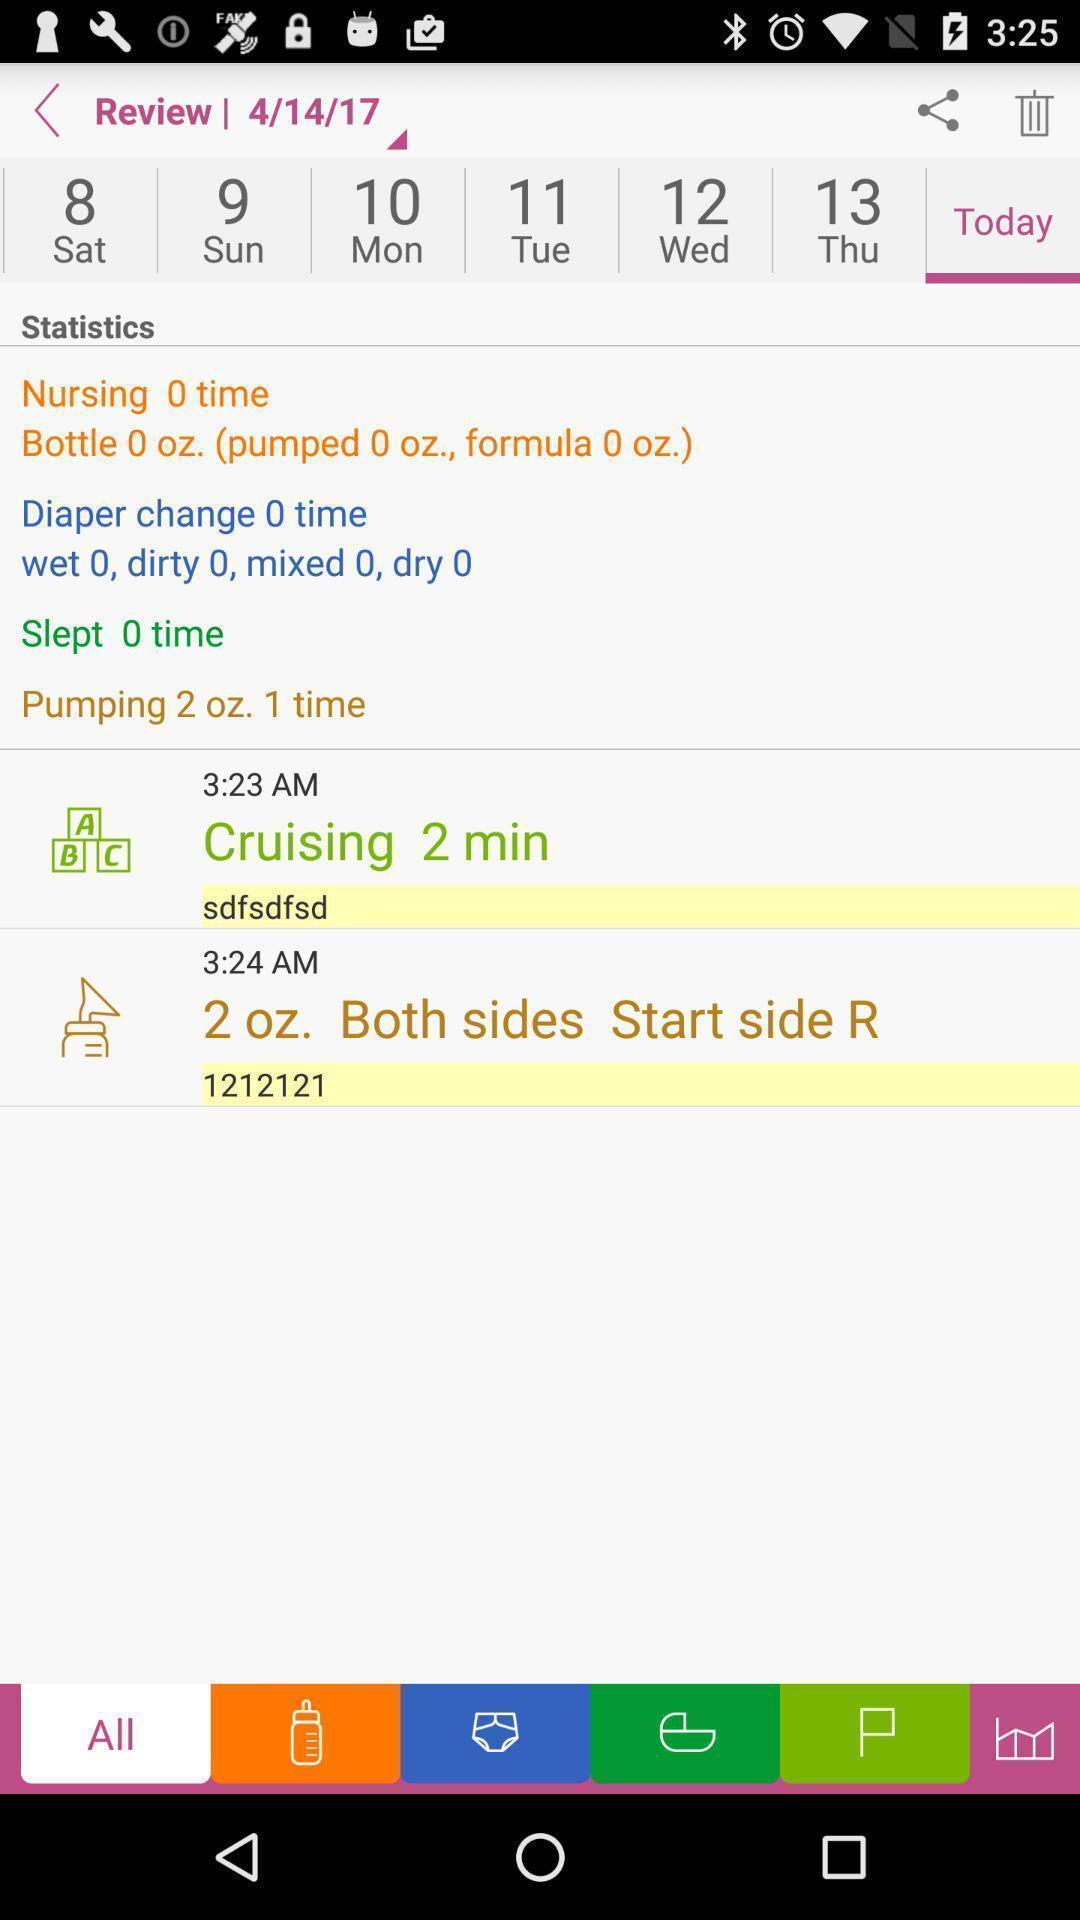Explain the elements present in this screenshot. Screen displaying the review page. 